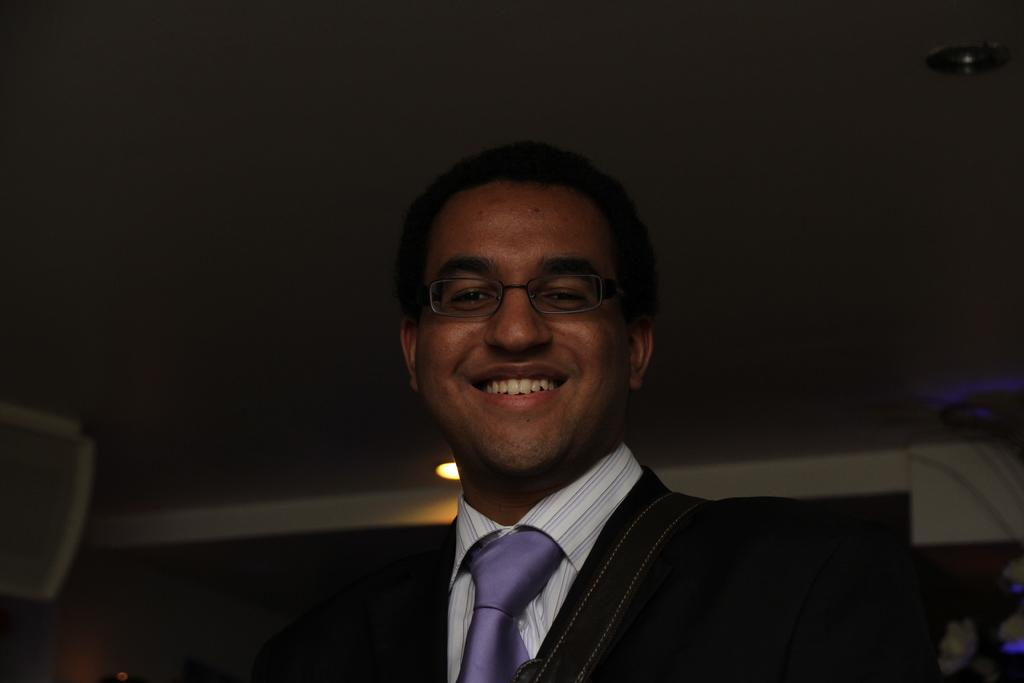What is the main subject of the image? There is a person in the image. What is the person wearing on their upper body? The person is wearing a black blazer and a white shirt. What type of accessory is the person wearing around their neck? The person is wearing a purple color tie. What can be seen in the background of the image? There is a light in the background of the image. What type of cake is being served as a good-bye treat in the image? There is no cake or good-bye event present in the image. What discovery was made by the person in the image? There is no indication of a discovery being made in the image. 